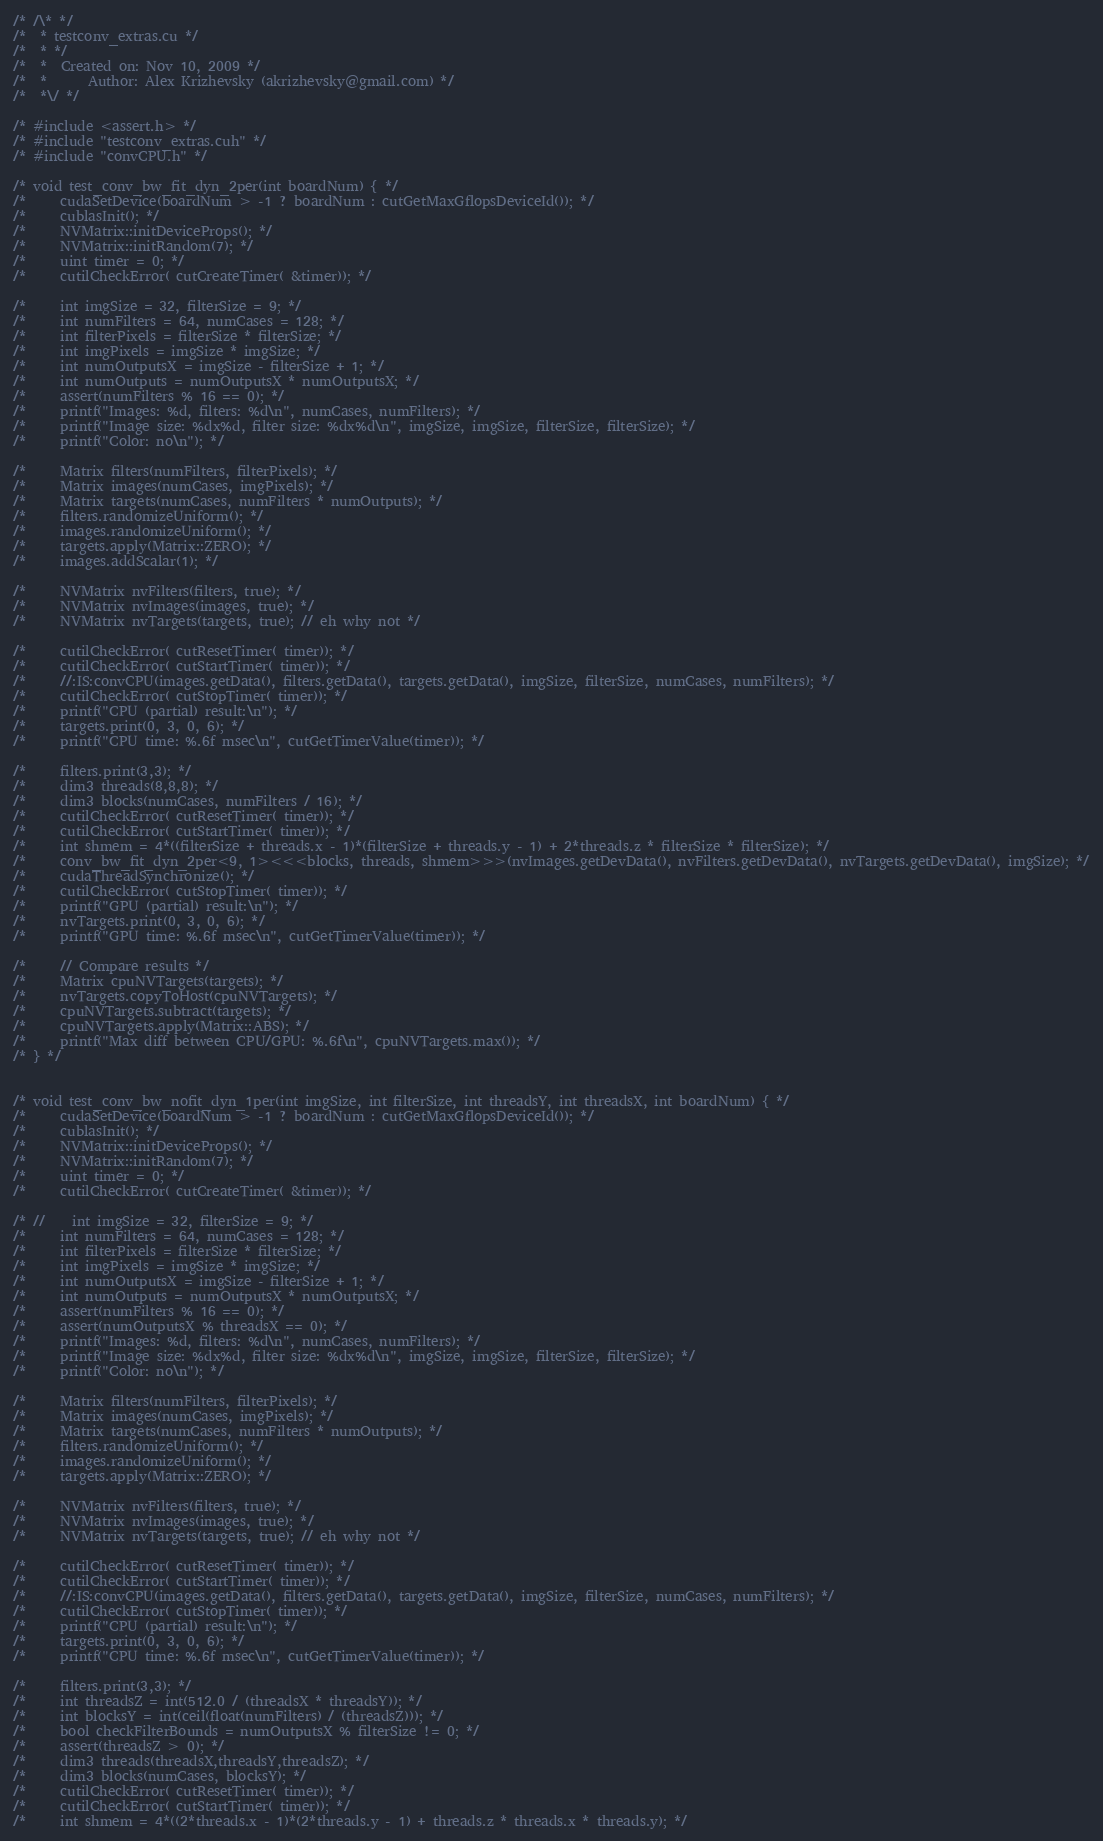Convert code to text. <code><loc_0><loc_0><loc_500><loc_500><_Cuda_>/* /\* */
/*  * testconv_extras.cu */
/*  * */
/*  *  Created on: Nov 10, 2009 */
/*  *      Author: Alex Krizhevsky (akrizhevsky@gmail.com) */
/*  *\/ */

/* #include <assert.h> */
/* #include "testconv_extras.cuh" */
/* #include "convCPU.h" */

/* void test_conv_bw_fit_dyn_2per(int boardNum) { */
/*     cudaSetDevice(boardNum > -1 ? boardNum : cutGetMaxGflopsDeviceId()); */
/*     cublasInit(); */
/*     NVMatrix::initDeviceProps(); */
/*     NVMatrix::initRandom(7); */
/*     uint timer = 0; */
/*     cutilCheckError( cutCreateTimer( &timer)); */

/*     int imgSize = 32, filterSize = 9; */
/*     int numFilters = 64, numCases = 128; */
/*     int filterPixels = filterSize * filterSize; */
/*     int imgPixels = imgSize * imgSize; */
/*     int numOutputsX = imgSize - filterSize + 1; */
/*     int numOutputs = numOutputsX * numOutputsX; */
/*     assert(numFilters % 16 == 0); */
/*     printf("Images: %d, filters: %d\n", numCases, numFilters); */
/*     printf("Image size: %dx%d, filter size: %dx%d\n", imgSize, imgSize, filterSize, filterSize); */
/*     printf("Color: no\n"); */

/*     Matrix filters(numFilters, filterPixels); */
/*     Matrix images(numCases, imgPixels); */
/*     Matrix targets(numCases, numFilters * numOutputs); */
/*     filters.randomizeUniform(); */
/*     images.randomizeUniform(); */
/*     targets.apply(Matrix::ZERO); */
/*     images.addScalar(1); */

/*     NVMatrix nvFilters(filters, true); */
/*     NVMatrix nvImages(images, true); */
/*     NVMatrix nvTargets(targets, true); // eh why not */

/*     cutilCheckError( cutResetTimer( timer)); */
/*     cutilCheckError( cutStartTimer( timer)); */
/*     //:IS:convCPU(images.getData(), filters.getData(), targets.getData(), imgSize, filterSize, numCases, numFilters); */
/*     cutilCheckError( cutStopTimer( timer)); */
/*     printf("CPU (partial) result:\n"); */
/*     targets.print(0, 3, 0, 6); */
/*     printf("CPU time: %.6f msec\n", cutGetTimerValue(timer)); */

/*     filters.print(3,3); */
/*     dim3 threads(8,8,8); */
/*     dim3 blocks(numCases, numFilters / 16); */
/*     cutilCheckError( cutResetTimer( timer)); */
/*     cutilCheckError( cutStartTimer( timer)); */
/*     int shmem = 4*((filterSize + threads.x - 1)*(filterSize + threads.y - 1) + 2*threads.z * filterSize * filterSize); */
/*     conv_bw_fit_dyn_2per<9, 1><<<blocks, threads, shmem>>>(nvImages.getDevData(), nvFilters.getDevData(), nvTargets.getDevData(), imgSize); */
/*     cudaThreadSynchronize(); */
/*     cutilCheckError( cutStopTimer( timer)); */
/*     printf("GPU (partial) result:\n"); */
/*     nvTargets.print(0, 3, 0, 6); */
/*     printf("GPU time: %.6f msec\n", cutGetTimerValue(timer)); */

/*     // Compare results */
/*     Matrix cpuNVTargets(targets); */
/*     nvTargets.copyToHost(cpuNVTargets); */
/*     cpuNVTargets.subtract(targets); */
/*     cpuNVTargets.apply(Matrix::ABS); */
/*     printf("Max diff between CPU/GPU: %.6f\n", cpuNVTargets.max()); */
/* } */


/* void test_conv_bw_nofit_dyn_1per(int imgSize, int filterSize, int threadsY, int threadsX, int boardNum) { */
/*     cudaSetDevice(boardNum > -1 ? boardNum : cutGetMaxGflopsDeviceId()); */
/*     cublasInit(); */
/*     NVMatrix::initDeviceProps(); */
/*     NVMatrix::initRandom(7); */
/*     uint timer = 0; */
/*     cutilCheckError( cutCreateTimer( &timer)); */

/* //    int imgSize = 32, filterSize = 9; */
/*     int numFilters = 64, numCases = 128; */
/*     int filterPixels = filterSize * filterSize; */
/*     int imgPixels = imgSize * imgSize; */
/*     int numOutputsX = imgSize - filterSize + 1; */
/*     int numOutputs = numOutputsX * numOutputsX; */
/*     assert(numFilters % 16 == 0); */
/*     assert(numOutputsX % threadsX == 0); */
/*     printf("Images: %d, filters: %d\n", numCases, numFilters); */
/*     printf("Image size: %dx%d, filter size: %dx%d\n", imgSize, imgSize, filterSize, filterSize); */
/*     printf("Color: no\n"); */

/*     Matrix filters(numFilters, filterPixels); */
/*     Matrix images(numCases, imgPixels); */
/*     Matrix targets(numCases, numFilters * numOutputs); */
/*     filters.randomizeUniform(); */
/*     images.randomizeUniform(); */
/*     targets.apply(Matrix::ZERO); */

/*     NVMatrix nvFilters(filters, true); */
/*     NVMatrix nvImages(images, true); */
/*     NVMatrix nvTargets(targets, true); // eh why not */

/*     cutilCheckError( cutResetTimer( timer)); */
/*     cutilCheckError( cutStartTimer( timer)); */
/*     //:IS:convCPU(images.getData(), filters.getData(), targets.getData(), imgSize, filterSize, numCases, numFilters); */
/*     cutilCheckError( cutStopTimer( timer)); */
/*     printf("CPU (partial) result:\n"); */
/*     targets.print(0, 3, 0, 6); */
/*     printf("CPU time: %.6f msec\n", cutGetTimerValue(timer)); */

/*     filters.print(3,3); */
/*     int threadsZ = int(512.0 / (threadsX * threadsY)); */
/*     int blocksY = int(ceil(float(numFilters) / (threadsZ))); */
/*     bool checkFilterBounds = numOutputsX % filterSize != 0; */
/*     assert(threadsZ > 0); */
/*     dim3 threads(threadsX,threadsY,threadsZ); */
/*     dim3 blocks(numCases, blocksY); */
/*     cutilCheckError( cutResetTimer( timer)); */
/*     cutilCheckError( cutStartTimer( timer)); */
/*     int shmem = 4*((2*threads.x - 1)*(2*threads.y - 1) + threads.z * threads.x * threads.y); */</code> 